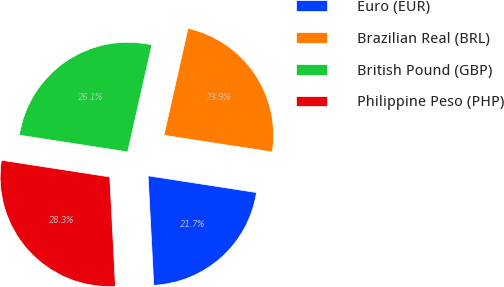Convert chart. <chart><loc_0><loc_0><loc_500><loc_500><pie_chart><fcel>Euro (EUR)<fcel>Brazilian Real (BRL)<fcel>British Pound (GBP)<fcel>Philippine Peso (PHP)<nl><fcel>21.74%<fcel>23.91%<fcel>26.09%<fcel>28.26%<nl></chart> 